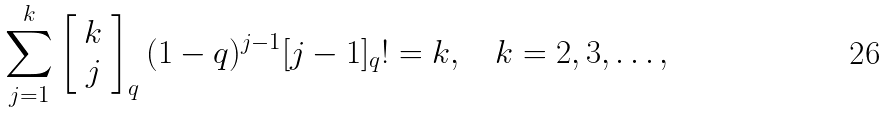<formula> <loc_0><loc_0><loc_500><loc_500>\sum _ { j = 1 } ^ { k } \left [ \begin{array} { c } k \\ j \end{array} \right ] _ { q } ( 1 - q ) ^ { j - 1 } [ j - 1 ] _ { q } ! = k , \quad k = 2 , 3 , \dots ,</formula> 